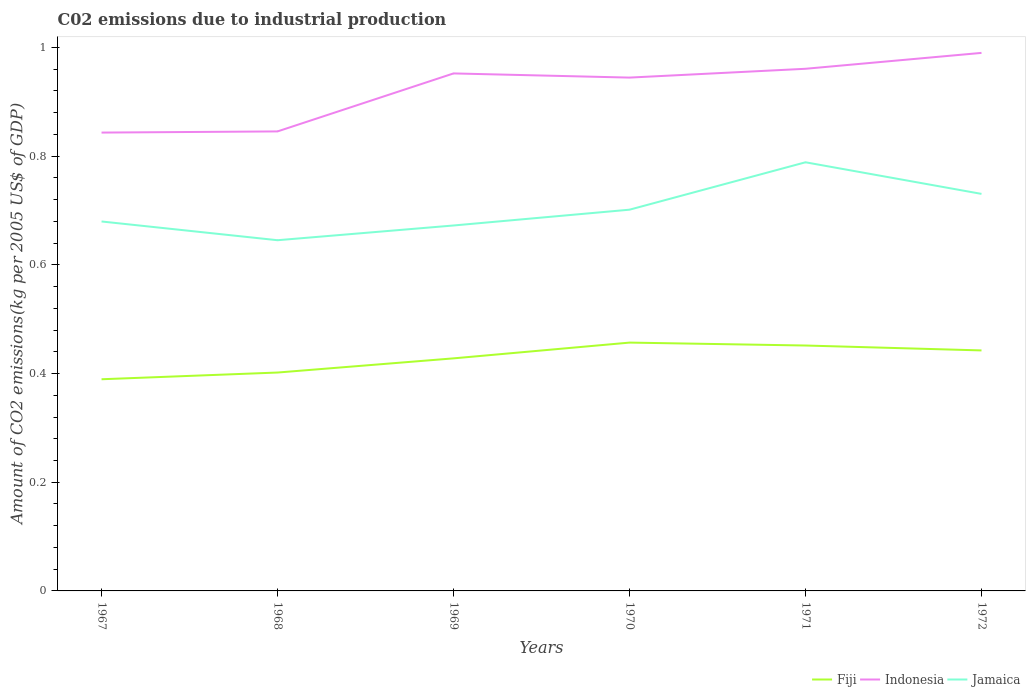Across all years, what is the maximum amount of CO2 emitted due to industrial production in Jamaica?
Offer a terse response. 0.65. In which year was the amount of CO2 emitted due to industrial production in Indonesia maximum?
Keep it short and to the point. 1967. What is the total amount of CO2 emitted due to industrial production in Fiji in the graph?
Offer a terse response. 0.01. What is the difference between the highest and the second highest amount of CO2 emitted due to industrial production in Jamaica?
Offer a terse response. 0.14. Are the values on the major ticks of Y-axis written in scientific E-notation?
Offer a very short reply. No. Does the graph contain grids?
Your response must be concise. No. Where does the legend appear in the graph?
Your answer should be very brief. Bottom right. How many legend labels are there?
Provide a succinct answer. 3. What is the title of the graph?
Your answer should be very brief. C02 emissions due to industrial production. What is the label or title of the X-axis?
Provide a succinct answer. Years. What is the label or title of the Y-axis?
Offer a very short reply. Amount of CO2 emissions(kg per 2005 US$ of GDP). What is the Amount of CO2 emissions(kg per 2005 US$ of GDP) of Fiji in 1967?
Your answer should be very brief. 0.39. What is the Amount of CO2 emissions(kg per 2005 US$ of GDP) of Indonesia in 1967?
Your answer should be very brief. 0.84. What is the Amount of CO2 emissions(kg per 2005 US$ of GDP) in Jamaica in 1967?
Keep it short and to the point. 0.68. What is the Amount of CO2 emissions(kg per 2005 US$ of GDP) of Fiji in 1968?
Offer a very short reply. 0.4. What is the Amount of CO2 emissions(kg per 2005 US$ of GDP) of Indonesia in 1968?
Give a very brief answer. 0.85. What is the Amount of CO2 emissions(kg per 2005 US$ of GDP) of Jamaica in 1968?
Provide a short and direct response. 0.65. What is the Amount of CO2 emissions(kg per 2005 US$ of GDP) of Fiji in 1969?
Provide a succinct answer. 0.43. What is the Amount of CO2 emissions(kg per 2005 US$ of GDP) in Indonesia in 1969?
Ensure brevity in your answer.  0.95. What is the Amount of CO2 emissions(kg per 2005 US$ of GDP) in Jamaica in 1969?
Your answer should be very brief. 0.67. What is the Amount of CO2 emissions(kg per 2005 US$ of GDP) in Fiji in 1970?
Offer a terse response. 0.46. What is the Amount of CO2 emissions(kg per 2005 US$ of GDP) of Indonesia in 1970?
Offer a terse response. 0.94. What is the Amount of CO2 emissions(kg per 2005 US$ of GDP) of Jamaica in 1970?
Provide a succinct answer. 0.7. What is the Amount of CO2 emissions(kg per 2005 US$ of GDP) of Fiji in 1971?
Offer a very short reply. 0.45. What is the Amount of CO2 emissions(kg per 2005 US$ of GDP) in Indonesia in 1971?
Ensure brevity in your answer.  0.96. What is the Amount of CO2 emissions(kg per 2005 US$ of GDP) of Jamaica in 1971?
Give a very brief answer. 0.79. What is the Amount of CO2 emissions(kg per 2005 US$ of GDP) in Fiji in 1972?
Give a very brief answer. 0.44. What is the Amount of CO2 emissions(kg per 2005 US$ of GDP) of Indonesia in 1972?
Ensure brevity in your answer.  0.99. What is the Amount of CO2 emissions(kg per 2005 US$ of GDP) in Jamaica in 1972?
Ensure brevity in your answer.  0.73. Across all years, what is the maximum Amount of CO2 emissions(kg per 2005 US$ of GDP) in Fiji?
Provide a short and direct response. 0.46. Across all years, what is the maximum Amount of CO2 emissions(kg per 2005 US$ of GDP) in Indonesia?
Make the answer very short. 0.99. Across all years, what is the maximum Amount of CO2 emissions(kg per 2005 US$ of GDP) of Jamaica?
Keep it short and to the point. 0.79. Across all years, what is the minimum Amount of CO2 emissions(kg per 2005 US$ of GDP) of Fiji?
Ensure brevity in your answer.  0.39. Across all years, what is the minimum Amount of CO2 emissions(kg per 2005 US$ of GDP) in Indonesia?
Provide a short and direct response. 0.84. Across all years, what is the minimum Amount of CO2 emissions(kg per 2005 US$ of GDP) in Jamaica?
Make the answer very short. 0.65. What is the total Amount of CO2 emissions(kg per 2005 US$ of GDP) of Fiji in the graph?
Keep it short and to the point. 2.57. What is the total Amount of CO2 emissions(kg per 2005 US$ of GDP) of Indonesia in the graph?
Provide a short and direct response. 5.54. What is the total Amount of CO2 emissions(kg per 2005 US$ of GDP) in Jamaica in the graph?
Give a very brief answer. 4.22. What is the difference between the Amount of CO2 emissions(kg per 2005 US$ of GDP) in Fiji in 1967 and that in 1968?
Your answer should be compact. -0.01. What is the difference between the Amount of CO2 emissions(kg per 2005 US$ of GDP) of Indonesia in 1967 and that in 1968?
Give a very brief answer. -0. What is the difference between the Amount of CO2 emissions(kg per 2005 US$ of GDP) of Jamaica in 1967 and that in 1968?
Your answer should be compact. 0.03. What is the difference between the Amount of CO2 emissions(kg per 2005 US$ of GDP) in Fiji in 1967 and that in 1969?
Ensure brevity in your answer.  -0.04. What is the difference between the Amount of CO2 emissions(kg per 2005 US$ of GDP) in Indonesia in 1967 and that in 1969?
Your response must be concise. -0.11. What is the difference between the Amount of CO2 emissions(kg per 2005 US$ of GDP) in Jamaica in 1967 and that in 1969?
Keep it short and to the point. 0.01. What is the difference between the Amount of CO2 emissions(kg per 2005 US$ of GDP) in Fiji in 1967 and that in 1970?
Make the answer very short. -0.07. What is the difference between the Amount of CO2 emissions(kg per 2005 US$ of GDP) in Indonesia in 1967 and that in 1970?
Your response must be concise. -0.1. What is the difference between the Amount of CO2 emissions(kg per 2005 US$ of GDP) in Jamaica in 1967 and that in 1970?
Provide a short and direct response. -0.02. What is the difference between the Amount of CO2 emissions(kg per 2005 US$ of GDP) of Fiji in 1967 and that in 1971?
Provide a short and direct response. -0.06. What is the difference between the Amount of CO2 emissions(kg per 2005 US$ of GDP) of Indonesia in 1967 and that in 1971?
Provide a short and direct response. -0.12. What is the difference between the Amount of CO2 emissions(kg per 2005 US$ of GDP) of Jamaica in 1967 and that in 1971?
Make the answer very short. -0.11. What is the difference between the Amount of CO2 emissions(kg per 2005 US$ of GDP) in Fiji in 1967 and that in 1972?
Your response must be concise. -0.05. What is the difference between the Amount of CO2 emissions(kg per 2005 US$ of GDP) of Indonesia in 1967 and that in 1972?
Give a very brief answer. -0.15. What is the difference between the Amount of CO2 emissions(kg per 2005 US$ of GDP) of Jamaica in 1967 and that in 1972?
Provide a succinct answer. -0.05. What is the difference between the Amount of CO2 emissions(kg per 2005 US$ of GDP) in Fiji in 1968 and that in 1969?
Your answer should be very brief. -0.03. What is the difference between the Amount of CO2 emissions(kg per 2005 US$ of GDP) in Indonesia in 1968 and that in 1969?
Your answer should be very brief. -0.11. What is the difference between the Amount of CO2 emissions(kg per 2005 US$ of GDP) of Jamaica in 1968 and that in 1969?
Your answer should be very brief. -0.03. What is the difference between the Amount of CO2 emissions(kg per 2005 US$ of GDP) of Fiji in 1968 and that in 1970?
Keep it short and to the point. -0.06. What is the difference between the Amount of CO2 emissions(kg per 2005 US$ of GDP) of Indonesia in 1968 and that in 1970?
Ensure brevity in your answer.  -0.1. What is the difference between the Amount of CO2 emissions(kg per 2005 US$ of GDP) in Jamaica in 1968 and that in 1970?
Your answer should be very brief. -0.06. What is the difference between the Amount of CO2 emissions(kg per 2005 US$ of GDP) in Fiji in 1968 and that in 1971?
Keep it short and to the point. -0.05. What is the difference between the Amount of CO2 emissions(kg per 2005 US$ of GDP) of Indonesia in 1968 and that in 1971?
Offer a very short reply. -0.12. What is the difference between the Amount of CO2 emissions(kg per 2005 US$ of GDP) of Jamaica in 1968 and that in 1971?
Your response must be concise. -0.14. What is the difference between the Amount of CO2 emissions(kg per 2005 US$ of GDP) of Fiji in 1968 and that in 1972?
Make the answer very short. -0.04. What is the difference between the Amount of CO2 emissions(kg per 2005 US$ of GDP) in Indonesia in 1968 and that in 1972?
Ensure brevity in your answer.  -0.14. What is the difference between the Amount of CO2 emissions(kg per 2005 US$ of GDP) in Jamaica in 1968 and that in 1972?
Your response must be concise. -0.09. What is the difference between the Amount of CO2 emissions(kg per 2005 US$ of GDP) of Fiji in 1969 and that in 1970?
Provide a short and direct response. -0.03. What is the difference between the Amount of CO2 emissions(kg per 2005 US$ of GDP) of Indonesia in 1969 and that in 1970?
Ensure brevity in your answer.  0.01. What is the difference between the Amount of CO2 emissions(kg per 2005 US$ of GDP) in Jamaica in 1969 and that in 1970?
Make the answer very short. -0.03. What is the difference between the Amount of CO2 emissions(kg per 2005 US$ of GDP) in Fiji in 1969 and that in 1971?
Your answer should be very brief. -0.02. What is the difference between the Amount of CO2 emissions(kg per 2005 US$ of GDP) of Indonesia in 1969 and that in 1971?
Offer a terse response. -0.01. What is the difference between the Amount of CO2 emissions(kg per 2005 US$ of GDP) in Jamaica in 1969 and that in 1971?
Provide a succinct answer. -0.12. What is the difference between the Amount of CO2 emissions(kg per 2005 US$ of GDP) of Fiji in 1969 and that in 1972?
Your answer should be very brief. -0.01. What is the difference between the Amount of CO2 emissions(kg per 2005 US$ of GDP) in Indonesia in 1969 and that in 1972?
Your answer should be compact. -0.04. What is the difference between the Amount of CO2 emissions(kg per 2005 US$ of GDP) in Jamaica in 1969 and that in 1972?
Provide a short and direct response. -0.06. What is the difference between the Amount of CO2 emissions(kg per 2005 US$ of GDP) in Fiji in 1970 and that in 1971?
Offer a very short reply. 0.01. What is the difference between the Amount of CO2 emissions(kg per 2005 US$ of GDP) in Indonesia in 1970 and that in 1971?
Make the answer very short. -0.02. What is the difference between the Amount of CO2 emissions(kg per 2005 US$ of GDP) in Jamaica in 1970 and that in 1971?
Your response must be concise. -0.09. What is the difference between the Amount of CO2 emissions(kg per 2005 US$ of GDP) of Fiji in 1970 and that in 1972?
Your answer should be compact. 0.01. What is the difference between the Amount of CO2 emissions(kg per 2005 US$ of GDP) of Indonesia in 1970 and that in 1972?
Ensure brevity in your answer.  -0.05. What is the difference between the Amount of CO2 emissions(kg per 2005 US$ of GDP) of Jamaica in 1970 and that in 1972?
Keep it short and to the point. -0.03. What is the difference between the Amount of CO2 emissions(kg per 2005 US$ of GDP) in Fiji in 1971 and that in 1972?
Give a very brief answer. 0.01. What is the difference between the Amount of CO2 emissions(kg per 2005 US$ of GDP) of Indonesia in 1971 and that in 1972?
Offer a very short reply. -0.03. What is the difference between the Amount of CO2 emissions(kg per 2005 US$ of GDP) of Jamaica in 1971 and that in 1972?
Offer a terse response. 0.06. What is the difference between the Amount of CO2 emissions(kg per 2005 US$ of GDP) of Fiji in 1967 and the Amount of CO2 emissions(kg per 2005 US$ of GDP) of Indonesia in 1968?
Provide a short and direct response. -0.46. What is the difference between the Amount of CO2 emissions(kg per 2005 US$ of GDP) of Fiji in 1967 and the Amount of CO2 emissions(kg per 2005 US$ of GDP) of Jamaica in 1968?
Provide a succinct answer. -0.26. What is the difference between the Amount of CO2 emissions(kg per 2005 US$ of GDP) of Indonesia in 1967 and the Amount of CO2 emissions(kg per 2005 US$ of GDP) of Jamaica in 1968?
Keep it short and to the point. 0.2. What is the difference between the Amount of CO2 emissions(kg per 2005 US$ of GDP) of Fiji in 1967 and the Amount of CO2 emissions(kg per 2005 US$ of GDP) of Indonesia in 1969?
Ensure brevity in your answer.  -0.56. What is the difference between the Amount of CO2 emissions(kg per 2005 US$ of GDP) in Fiji in 1967 and the Amount of CO2 emissions(kg per 2005 US$ of GDP) in Jamaica in 1969?
Your answer should be compact. -0.28. What is the difference between the Amount of CO2 emissions(kg per 2005 US$ of GDP) of Indonesia in 1967 and the Amount of CO2 emissions(kg per 2005 US$ of GDP) of Jamaica in 1969?
Your answer should be compact. 0.17. What is the difference between the Amount of CO2 emissions(kg per 2005 US$ of GDP) of Fiji in 1967 and the Amount of CO2 emissions(kg per 2005 US$ of GDP) of Indonesia in 1970?
Make the answer very short. -0.56. What is the difference between the Amount of CO2 emissions(kg per 2005 US$ of GDP) of Fiji in 1967 and the Amount of CO2 emissions(kg per 2005 US$ of GDP) of Jamaica in 1970?
Provide a succinct answer. -0.31. What is the difference between the Amount of CO2 emissions(kg per 2005 US$ of GDP) in Indonesia in 1967 and the Amount of CO2 emissions(kg per 2005 US$ of GDP) in Jamaica in 1970?
Offer a very short reply. 0.14. What is the difference between the Amount of CO2 emissions(kg per 2005 US$ of GDP) in Fiji in 1967 and the Amount of CO2 emissions(kg per 2005 US$ of GDP) in Indonesia in 1971?
Give a very brief answer. -0.57. What is the difference between the Amount of CO2 emissions(kg per 2005 US$ of GDP) of Fiji in 1967 and the Amount of CO2 emissions(kg per 2005 US$ of GDP) of Jamaica in 1971?
Offer a terse response. -0.4. What is the difference between the Amount of CO2 emissions(kg per 2005 US$ of GDP) of Indonesia in 1967 and the Amount of CO2 emissions(kg per 2005 US$ of GDP) of Jamaica in 1971?
Provide a succinct answer. 0.05. What is the difference between the Amount of CO2 emissions(kg per 2005 US$ of GDP) of Fiji in 1967 and the Amount of CO2 emissions(kg per 2005 US$ of GDP) of Indonesia in 1972?
Provide a succinct answer. -0.6. What is the difference between the Amount of CO2 emissions(kg per 2005 US$ of GDP) in Fiji in 1967 and the Amount of CO2 emissions(kg per 2005 US$ of GDP) in Jamaica in 1972?
Keep it short and to the point. -0.34. What is the difference between the Amount of CO2 emissions(kg per 2005 US$ of GDP) of Indonesia in 1967 and the Amount of CO2 emissions(kg per 2005 US$ of GDP) of Jamaica in 1972?
Your answer should be very brief. 0.11. What is the difference between the Amount of CO2 emissions(kg per 2005 US$ of GDP) of Fiji in 1968 and the Amount of CO2 emissions(kg per 2005 US$ of GDP) of Indonesia in 1969?
Give a very brief answer. -0.55. What is the difference between the Amount of CO2 emissions(kg per 2005 US$ of GDP) in Fiji in 1968 and the Amount of CO2 emissions(kg per 2005 US$ of GDP) in Jamaica in 1969?
Offer a very short reply. -0.27. What is the difference between the Amount of CO2 emissions(kg per 2005 US$ of GDP) of Indonesia in 1968 and the Amount of CO2 emissions(kg per 2005 US$ of GDP) of Jamaica in 1969?
Your answer should be compact. 0.17. What is the difference between the Amount of CO2 emissions(kg per 2005 US$ of GDP) of Fiji in 1968 and the Amount of CO2 emissions(kg per 2005 US$ of GDP) of Indonesia in 1970?
Make the answer very short. -0.54. What is the difference between the Amount of CO2 emissions(kg per 2005 US$ of GDP) in Fiji in 1968 and the Amount of CO2 emissions(kg per 2005 US$ of GDP) in Jamaica in 1970?
Your answer should be compact. -0.3. What is the difference between the Amount of CO2 emissions(kg per 2005 US$ of GDP) in Indonesia in 1968 and the Amount of CO2 emissions(kg per 2005 US$ of GDP) in Jamaica in 1970?
Offer a very short reply. 0.14. What is the difference between the Amount of CO2 emissions(kg per 2005 US$ of GDP) of Fiji in 1968 and the Amount of CO2 emissions(kg per 2005 US$ of GDP) of Indonesia in 1971?
Ensure brevity in your answer.  -0.56. What is the difference between the Amount of CO2 emissions(kg per 2005 US$ of GDP) of Fiji in 1968 and the Amount of CO2 emissions(kg per 2005 US$ of GDP) of Jamaica in 1971?
Give a very brief answer. -0.39. What is the difference between the Amount of CO2 emissions(kg per 2005 US$ of GDP) of Indonesia in 1968 and the Amount of CO2 emissions(kg per 2005 US$ of GDP) of Jamaica in 1971?
Offer a very short reply. 0.06. What is the difference between the Amount of CO2 emissions(kg per 2005 US$ of GDP) in Fiji in 1968 and the Amount of CO2 emissions(kg per 2005 US$ of GDP) in Indonesia in 1972?
Provide a succinct answer. -0.59. What is the difference between the Amount of CO2 emissions(kg per 2005 US$ of GDP) in Fiji in 1968 and the Amount of CO2 emissions(kg per 2005 US$ of GDP) in Jamaica in 1972?
Keep it short and to the point. -0.33. What is the difference between the Amount of CO2 emissions(kg per 2005 US$ of GDP) of Indonesia in 1968 and the Amount of CO2 emissions(kg per 2005 US$ of GDP) of Jamaica in 1972?
Offer a terse response. 0.12. What is the difference between the Amount of CO2 emissions(kg per 2005 US$ of GDP) of Fiji in 1969 and the Amount of CO2 emissions(kg per 2005 US$ of GDP) of Indonesia in 1970?
Provide a short and direct response. -0.52. What is the difference between the Amount of CO2 emissions(kg per 2005 US$ of GDP) in Fiji in 1969 and the Amount of CO2 emissions(kg per 2005 US$ of GDP) in Jamaica in 1970?
Give a very brief answer. -0.27. What is the difference between the Amount of CO2 emissions(kg per 2005 US$ of GDP) in Indonesia in 1969 and the Amount of CO2 emissions(kg per 2005 US$ of GDP) in Jamaica in 1970?
Provide a succinct answer. 0.25. What is the difference between the Amount of CO2 emissions(kg per 2005 US$ of GDP) in Fiji in 1969 and the Amount of CO2 emissions(kg per 2005 US$ of GDP) in Indonesia in 1971?
Provide a succinct answer. -0.53. What is the difference between the Amount of CO2 emissions(kg per 2005 US$ of GDP) of Fiji in 1969 and the Amount of CO2 emissions(kg per 2005 US$ of GDP) of Jamaica in 1971?
Ensure brevity in your answer.  -0.36. What is the difference between the Amount of CO2 emissions(kg per 2005 US$ of GDP) of Indonesia in 1969 and the Amount of CO2 emissions(kg per 2005 US$ of GDP) of Jamaica in 1971?
Provide a succinct answer. 0.16. What is the difference between the Amount of CO2 emissions(kg per 2005 US$ of GDP) of Fiji in 1969 and the Amount of CO2 emissions(kg per 2005 US$ of GDP) of Indonesia in 1972?
Provide a short and direct response. -0.56. What is the difference between the Amount of CO2 emissions(kg per 2005 US$ of GDP) of Fiji in 1969 and the Amount of CO2 emissions(kg per 2005 US$ of GDP) of Jamaica in 1972?
Provide a short and direct response. -0.3. What is the difference between the Amount of CO2 emissions(kg per 2005 US$ of GDP) of Indonesia in 1969 and the Amount of CO2 emissions(kg per 2005 US$ of GDP) of Jamaica in 1972?
Ensure brevity in your answer.  0.22. What is the difference between the Amount of CO2 emissions(kg per 2005 US$ of GDP) in Fiji in 1970 and the Amount of CO2 emissions(kg per 2005 US$ of GDP) in Indonesia in 1971?
Provide a short and direct response. -0.5. What is the difference between the Amount of CO2 emissions(kg per 2005 US$ of GDP) in Fiji in 1970 and the Amount of CO2 emissions(kg per 2005 US$ of GDP) in Jamaica in 1971?
Offer a very short reply. -0.33. What is the difference between the Amount of CO2 emissions(kg per 2005 US$ of GDP) in Indonesia in 1970 and the Amount of CO2 emissions(kg per 2005 US$ of GDP) in Jamaica in 1971?
Your answer should be very brief. 0.16. What is the difference between the Amount of CO2 emissions(kg per 2005 US$ of GDP) of Fiji in 1970 and the Amount of CO2 emissions(kg per 2005 US$ of GDP) of Indonesia in 1972?
Provide a succinct answer. -0.53. What is the difference between the Amount of CO2 emissions(kg per 2005 US$ of GDP) in Fiji in 1970 and the Amount of CO2 emissions(kg per 2005 US$ of GDP) in Jamaica in 1972?
Your answer should be very brief. -0.27. What is the difference between the Amount of CO2 emissions(kg per 2005 US$ of GDP) of Indonesia in 1970 and the Amount of CO2 emissions(kg per 2005 US$ of GDP) of Jamaica in 1972?
Provide a succinct answer. 0.21. What is the difference between the Amount of CO2 emissions(kg per 2005 US$ of GDP) in Fiji in 1971 and the Amount of CO2 emissions(kg per 2005 US$ of GDP) in Indonesia in 1972?
Provide a short and direct response. -0.54. What is the difference between the Amount of CO2 emissions(kg per 2005 US$ of GDP) of Fiji in 1971 and the Amount of CO2 emissions(kg per 2005 US$ of GDP) of Jamaica in 1972?
Your response must be concise. -0.28. What is the difference between the Amount of CO2 emissions(kg per 2005 US$ of GDP) of Indonesia in 1971 and the Amount of CO2 emissions(kg per 2005 US$ of GDP) of Jamaica in 1972?
Offer a very short reply. 0.23. What is the average Amount of CO2 emissions(kg per 2005 US$ of GDP) of Fiji per year?
Offer a terse response. 0.43. What is the average Amount of CO2 emissions(kg per 2005 US$ of GDP) in Indonesia per year?
Offer a terse response. 0.92. What is the average Amount of CO2 emissions(kg per 2005 US$ of GDP) in Jamaica per year?
Keep it short and to the point. 0.7. In the year 1967, what is the difference between the Amount of CO2 emissions(kg per 2005 US$ of GDP) in Fiji and Amount of CO2 emissions(kg per 2005 US$ of GDP) in Indonesia?
Your response must be concise. -0.45. In the year 1967, what is the difference between the Amount of CO2 emissions(kg per 2005 US$ of GDP) in Fiji and Amount of CO2 emissions(kg per 2005 US$ of GDP) in Jamaica?
Your answer should be compact. -0.29. In the year 1967, what is the difference between the Amount of CO2 emissions(kg per 2005 US$ of GDP) of Indonesia and Amount of CO2 emissions(kg per 2005 US$ of GDP) of Jamaica?
Provide a short and direct response. 0.16. In the year 1968, what is the difference between the Amount of CO2 emissions(kg per 2005 US$ of GDP) in Fiji and Amount of CO2 emissions(kg per 2005 US$ of GDP) in Indonesia?
Keep it short and to the point. -0.44. In the year 1968, what is the difference between the Amount of CO2 emissions(kg per 2005 US$ of GDP) in Fiji and Amount of CO2 emissions(kg per 2005 US$ of GDP) in Jamaica?
Give a very brief answer. -0.24. In the year 1968, what is the difference between the Amount of CO2 emissions(kg per 2005 US$ of GDP) of Indonesia and Amount of CO2 emissions(kg per 2005 US$ of GDP) of Jamaica?
Provide a succinct answer. 0.2. In the year 1969, what is the difference between the Amount of CO2 emissions(kg per 2005 US$ of GDP) of Fiji and Amount of CO2 emissions(kg per 2005 US$ of GDP) of Indonesia?
Offer a terse response. -0.52. In the year 1969, what is the difference between the Amount of CO2 emissions(kg per 2005 US$ of GDP) in Fiji and Amount of CO2 emissions(kg per 2005 US$ of GDP) in Jamaica?
Your answer should be very brief. -0.24. In the year 1969, what is the difference between the Amount of CO2 emissions(kg per 2005 US$ of GDP) in Indonesia and Amount of CO2 emissions(kg per 2005 US$ of GDP) in Jamaica?
Ensure brevity in your answer.  0.28. In the year 1970, what is the difference between the Amount of CO2 emissions(kg per 2005 US$ of GDP) of Fiji and Amount of CO2 emissions(kg per 2005 US$ of GDP) of Indonesia?
Offer a very short reply. -0.49. In the year 1970, what is the difference between the Amount of CO2 emissions(kg per 2005 US$ of GDP) of Fiji and Amount of CO2 emissions(kg per 2005 US$ of GDP) of Jamaica?
Ensure brevity in your answer.  -0.24. In the year 1970, what is the difference between the Amount of CO2 emissions(kg per 2005 US$ of GDP) in Indonesia and Amount of CO2 emissions(kg per 2005 US$ of GDP) in Jamaica?
Your response must be concise. 0.24. In the year 1971, what is the difference between the Amount of CO2 emissions(kg per 2005 US$ of GDP) of Fiji and Amount of CO2 emissions(kg per 2005 US$ of GDP) of Indonesia?
Provide a succinct answer. -0.51. In the year 1971, what is the difference between the Amount of CO2 emissions(kg per 2005 US$ of GDP) in Fiji and Amount of CO2 emissions(kg per 2005 US$ of GDP) in Jamaica?
Ensure brevity in your answer.  -0.34. In the year 1971, what is the difference between the Amount of CO2 emissions(kg per 2005 US$ of GDP) in Indonesia and Amount of CO2 emissions(kg per 2005 US$ of GDP) in Jamaica?
Give a very brief answer. 0.17. In the year 1972, what is the difference between the Amount of CO2 emissions(kg per 2005 US$ of GDP) of Fiji and Amount of CO2 emissions(kg per 2005 US$ of GDP) of Indonesia?
Offer a very short reply. -0.55. In the year 1972, what is the difference between the Amount of CO2 emissions(kg per 2005 US$ of GDP) in Fiji and Amount of CO2 emissions(kg per 2005 US$ of GDP) in Jamaica?
Make the answer very short. -0.29. In the year 1972, what is the difference between the Amount of CO2 emissions(kg per 2005 US$ of GDP) of Indonesia and Amount of CO2 emissions(kg per 2005 US$ of GDP) of Jamaica?
Make the answer very short. 0.26. What is the ratio of the Amount of CO2 emissions(kg per 2005 US$ of GDP) in Fiji in 1967 to that in 1968?
Your response must be concise. 0.97. What is the ratio of the Amount of CO2 emissions(kg per 2005 US$ of GDP) in Indonesia in 1967 to that in 1968?
Offer a terse response. 1. What is the ratio of the Amount of CO2 emissions(kg per 2005 US$ of GDP) in Jamaica in 1967 to that in 1968?
Your response must be concise. 1.05. What is the ratio of the Amount of CO2 emissions(kg per 2005 US$ of GDP) of Fiji in 1967 to that in 1969?
Keep it short and to the point. 0.91. What is the ratio of the Amount of CO2 emissions(kg per 2005 US$ of GDP) in Indonesia in 1967 to that in 1969?
Your answer should be compact. 0.89. What is the ratio of the Amount of CO2 emissions(kg per 2005 US$ of GDP) in Fiji in 1967 to that in 1970?
Keep it short and to the point. 0.85. What is the ratio of the Amount of CO2 emissions(kg per 2005 US$ of GDP) of Indonesia in 1967 to that in 1970?
Your response must be concise. 0.89. What is the ratio of the Amount of CO2 emissions(kg per 2005 US$ of GDP) in Jamaica in 1967 to that in 1970?
Provide a short and direct response. 0.97. What is the ratio of the Amount of CO2 emissions(kg per 2005 US$ of GDP) of Fiji in 1967 to that in 1971?
Provide a short and direct response. 0.86. What is the ratio of the Amount of CO2 emissions(kg per 2005 US$ of GDP) in Indonesia in 1967 to that in 1971?
Make the answer very short. 0.88. What is the ratio of the Amount of CO2 emissions(kg per 2005 US$ of GDP) of Jamaica in 1967 to that in 1971?
Make the answer very short. 0.86. What is the ratio of the Amount of CO2 emissions(kg per 2005 US$ of GDP) of Fiji in 1967 to that in 1972?
Your response must be concise. 0.88. What is the ratio of the Amount of CO2 emissions(kg per 2005 US$ of GDP) of Indonesia in 1967 to that in 1972?
Offer a terse response. 0.85. What is the ratio of the Amount of CO2 emissions(kg per 2005 US$ of GDP) of Jamaica in 1967 to that in 1972?
Offer a terse response. 0.93. What is the ratio of the Amount of CO2 emissions(kg per 2005 US$ of GDP) of Fiji in 1968 to that in 1969?
Your answer should be very brief. 0.94. What is the ratio of the Amount of CO2 emissions(kg per 2005 US$ of GDP) in Indonesia in 1968 to that in 1969?
Offer a terse response. 0.89. What is the ratio of the Amount of CO2 emissions(kg per 2005 US$ of GDP) of Jamaica in 1968 to that in 1969?
Offer a very short reply. 0.96. What is the ratio of the Amount of CO2 emissions(kg per 2005 US$ of GDP) in Fiji in 1968 to that in 1970?
Keep it short and to the point. 0.88. What is the ratio of the Amount of CO2 emissions(kg per 2005 US$ of GDP) of Indonesia in 1968 to that in 1970?
Give a very brief answer. 0.9. What is the ratio of the Amount of CO2 emissions(kg per 2005 US$ of GDP) in Jamaica in 1968 to that in 1970?
Offer a very short reply. 0.92. What is the ratio of the Amount of CO2 emissions(kg per 2005 US$ of GDP) of Fiji in 1968 to that in 1971?
Provide a succinct answer. 0.89. What is the ratio of the Amount of CO2 emissions(kg per 2005 US$ of GDP) of Jamaica in 1968 to that in 1971?
Offer a terse response. 0.82. What is the ratio of the Amount of CO2 emissions(kg per 2005 US$ of GDP) of Fiji in 1968 to that in 1972?
Ensure brevity in your answer.  0.91. What is the ratio of the Amount of CO2 emissions(kg per 2005 US$ of GDP) in Indonesia in 1968 to that in 1972?
Provide a short and direct response. 0.85. What is the ratio of the Amount of CO2 emissions(kg per 2005 US$ of GDP) of Jamaica in 1968 to that in 1972?
Ensure brevity in your answer.  0.88. What is the ratio of the Amount of CO2 emissions(kg per 2005 US$ of GDP) of Fiji in 1969 to that in 1970?
Your answer should be very brief. 0.94. What is the ratio of the Amount of CO2 emissions(kg per 2005 US$ of GDP) in Jamaica in 1969 to that in 1970?
Make the answer very short. 0.96. What is the ratio of the Amount of CO2 emissions(kg per 2005 US$ of GDP) of Fiji in 1969 to that in 1971?
Keep it short and to the point. 0.95. What is the ratio of the Amount of CO2 emissions(kg per 2005 US$ of GDP) in Jamaica in 1969 to that in 1971?
Your answer should be very brief. 0.85. What is the ratio of the Amount of CO2 emissions(kg per 2005 US$ of GDP) of Fiji in 1969 to that in 1972?
Your response must be concise. 0.97. What is the ratio of the Amount of CO2 emissions(kg per 2005 US$ of GDP) in Indonesia in 1969 to that in 1972?
Make the answer very short. 0.96. What is the ratio of the Amount of CO2 emissions(kg per 2005 US$ of GDP) of Jamaica in 1969 to that in 1972?
Provide a succinct answer. 0.92. What is the ratio of the Amount of CO2 emissions(kg per 2005 US$ of GDP) in Fiji in 1970 to that in 1971?
Provide a short and direct response. 1.01. What is the ratio of the Amount of CO2 emissions(kg per 2005 US$ of GDP) of Indonesia in 1970 to that in 1971?
Offer a very short reply. 0.98. What is the ratio of the Amount of CO2 emissions(kg per 2005 US$ of GDP) of Jamaica in 1970 to that in 1971?
Provide a succinct answer. 0.89. What is the ratio of the Amount of CO2 emissions(kg per 2005 US$ of GDP) in Fiji in 1970 to that in 1972?
Make the answer very short. 1.03. What is the ratio of the Amount of CO2 emissions(kg per 2005 US$ of GDP) of Indonesia in 1970 to that in 1972?
Give a very brief answer. 0.95. What is the ratio of the Amount of CO2 emissions(kg per 2005 US$ of GDP) in Jamaica in 1970 to that in 1972?
Offer a terse response. 0.96. What is the ratio of the Amount of CO2 emissions(kg per 2005 US$ of GDP) of Fiji in 1971 to that in 1972?
Offer a very short reply. 1.02. What is the ratio of the Amount of CO2 emissions(kg per 2005 US$ of GDP) of Indonesia in 1971 to that in 1972?
Your response must be concise. 0.97. What is the ratio of the Amount of CO2 emissions(kg per 2005 US$ of GDP) of Jamaica in 1971 to that in 1972?
Give a very brief answer. 1.08. What is the difference between the highest and the second highest Amount of CO2 emissions(kg per 2005 US$ of GDP) in Fiji?
Offer a terse response. 0.01. What is the difference between the highest and the second highest Amount of CO2 emissions(kg per 2005 US$ of GDP) of Indonesia?
Offer a terse response. 0.03. What is the difference between the highest and the second highest Amount of CO2 emissions(kg per 2005 US$ of GDP) in Jamaica?
Make the answer very short. 0.06. What is the difference between the highest and the lowest Amount of CO2 emissions(kg per 2005 US$ of GDP) in Fiji?
Your answer should be compact. 0.07. What is the difference between the highest and the lowest Amount of CO2 emissions(kg per 2005 US$ of GDP) of Indonesia?
Your response must be concise. 0.15. What is the difference between the highest and the lowest Amount of CO2 emissions(kg per 2005 US$ of GDP) in Jamaica?
Your answer should be very brief. 0.14. 